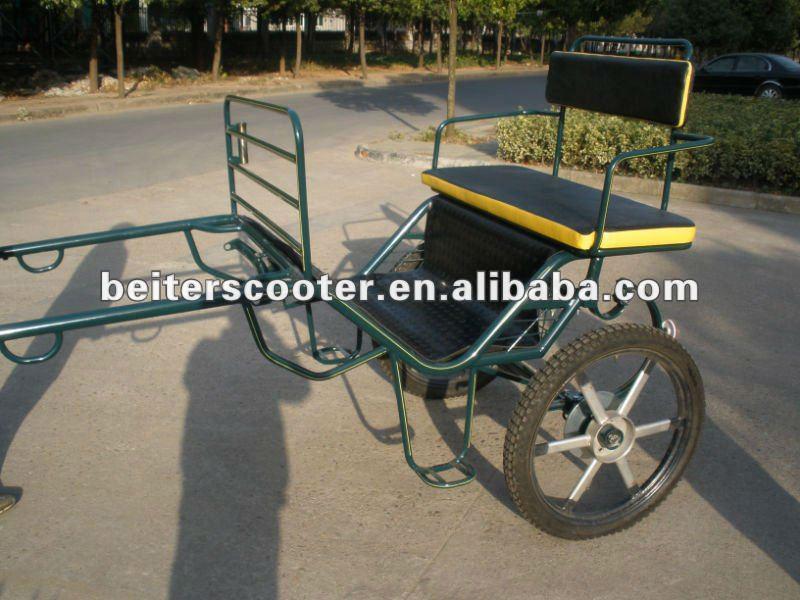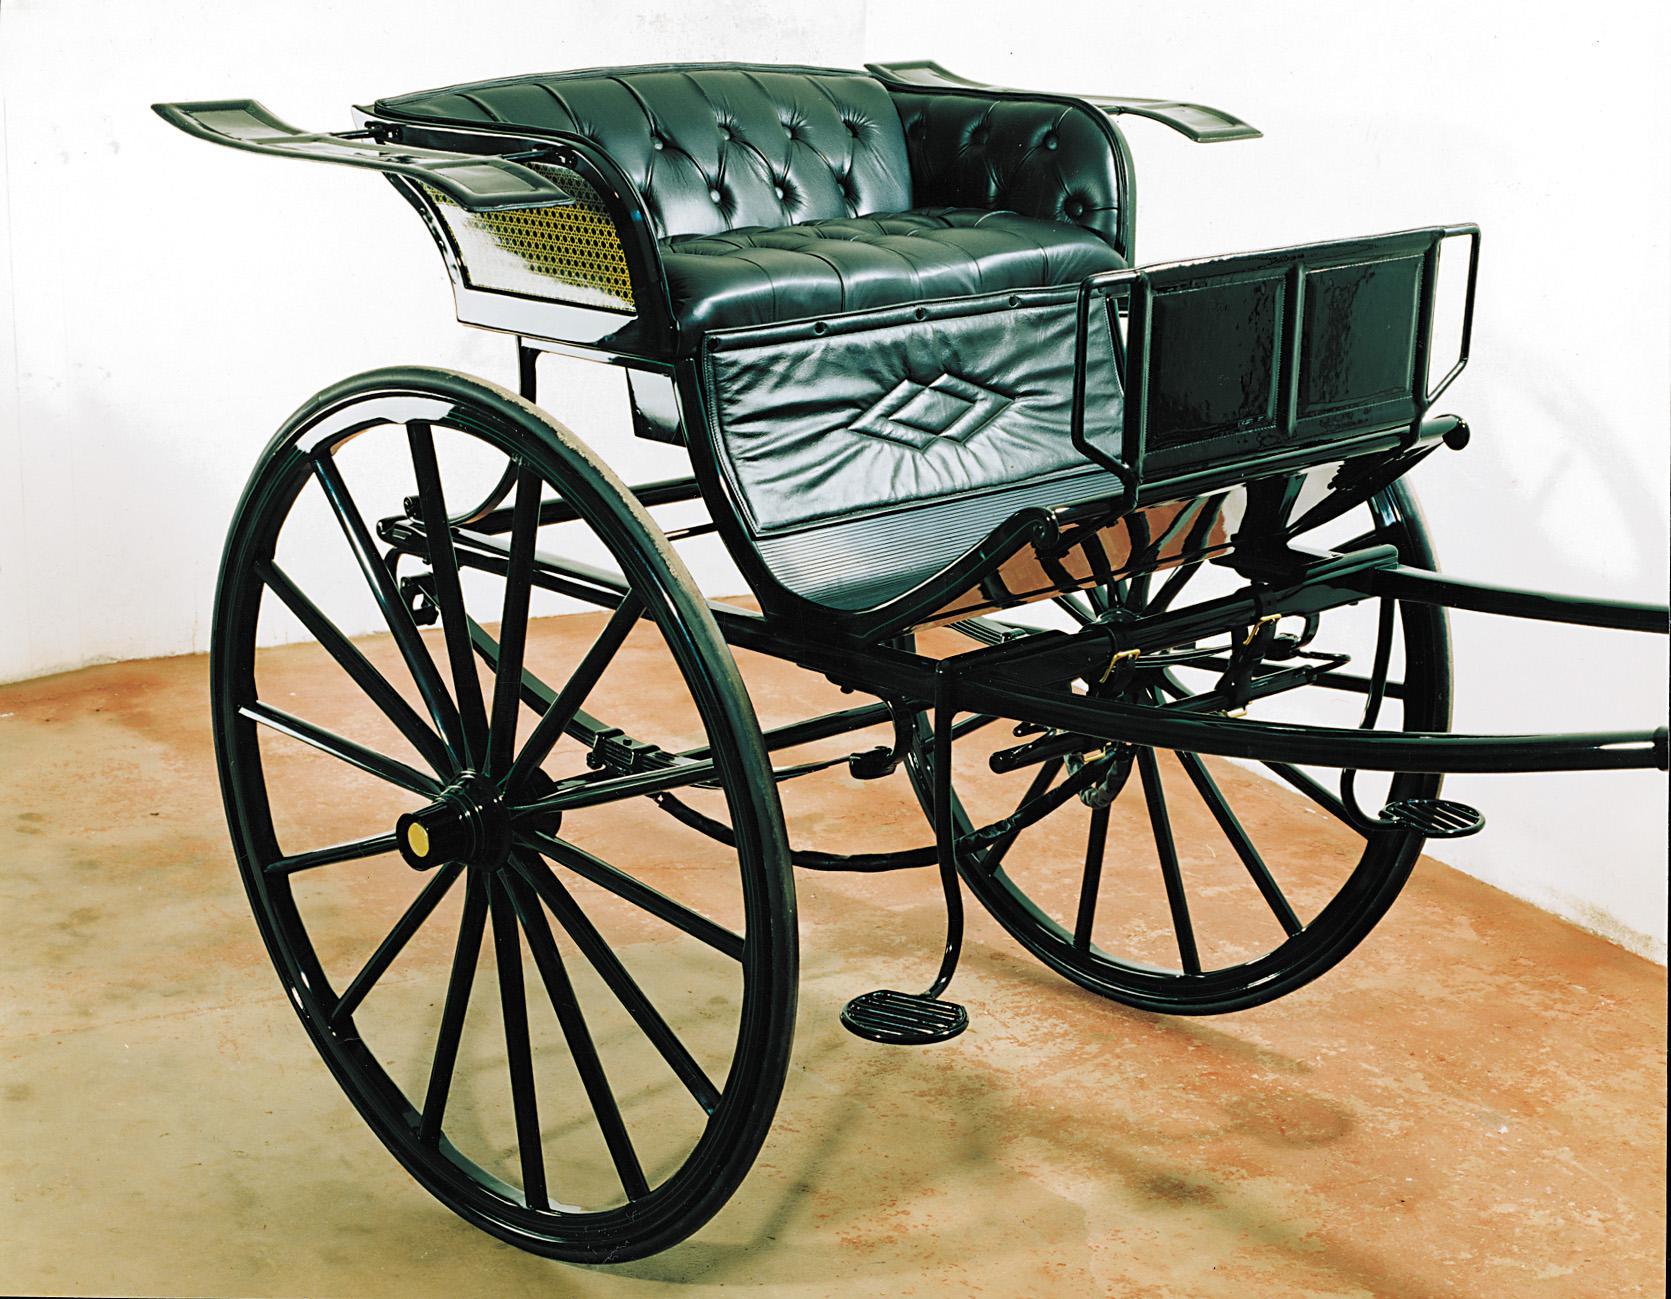The first image is the image on the left, the second image is the image on the right. Given the left and right images, does the statement "Both carriages are facing right." hold true? Answer yes or no. No. The first image is the image on the left, the second image is the image on the right. Assess this claim about the two images: "There is a carriage next to a paved road in the left image.". Correct or not? Answer yes or no. Yes. 